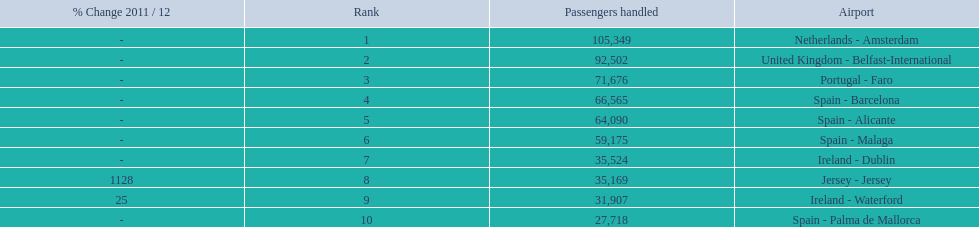What are all of the airports? Netherlands - Amsterdam, United Kingdom - Belfast-International, Portugal - Faro, Spain - Barcelona, Spain - Alicante, Spain - Malaga, Ireland - Dublin, Jersey - Jersey, Ireland - Waterford, Spain - Palma de Mallorca. How many passengers have they handled? 105,349, 92,502, 71,676, 66,565, 64,090, 59,175, 35,524, 35,169, 31,907, 27,718. And which airport has handled the most passengers? Netherlands - Amsterdam. 